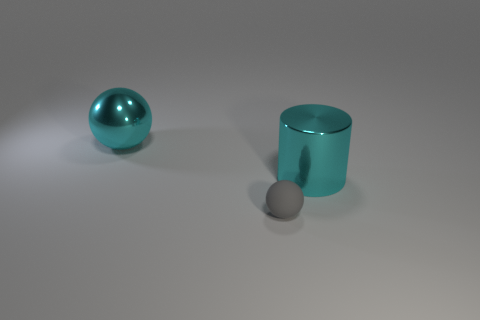Add 3 big red metal blocks. How many objects exist? 6 Subtract all spheres. How many objects are left? 1 Subtract 1 cyan balls. How many objects are left? 2 Subtract all large cylinders. Subtract all big balls. How many objects are left? 1 Add 3 large cyan metallic things. How many large cyan metallic things are left? 5 Add 3 large cyan cubes. How many large cyan cubes exist? 3 